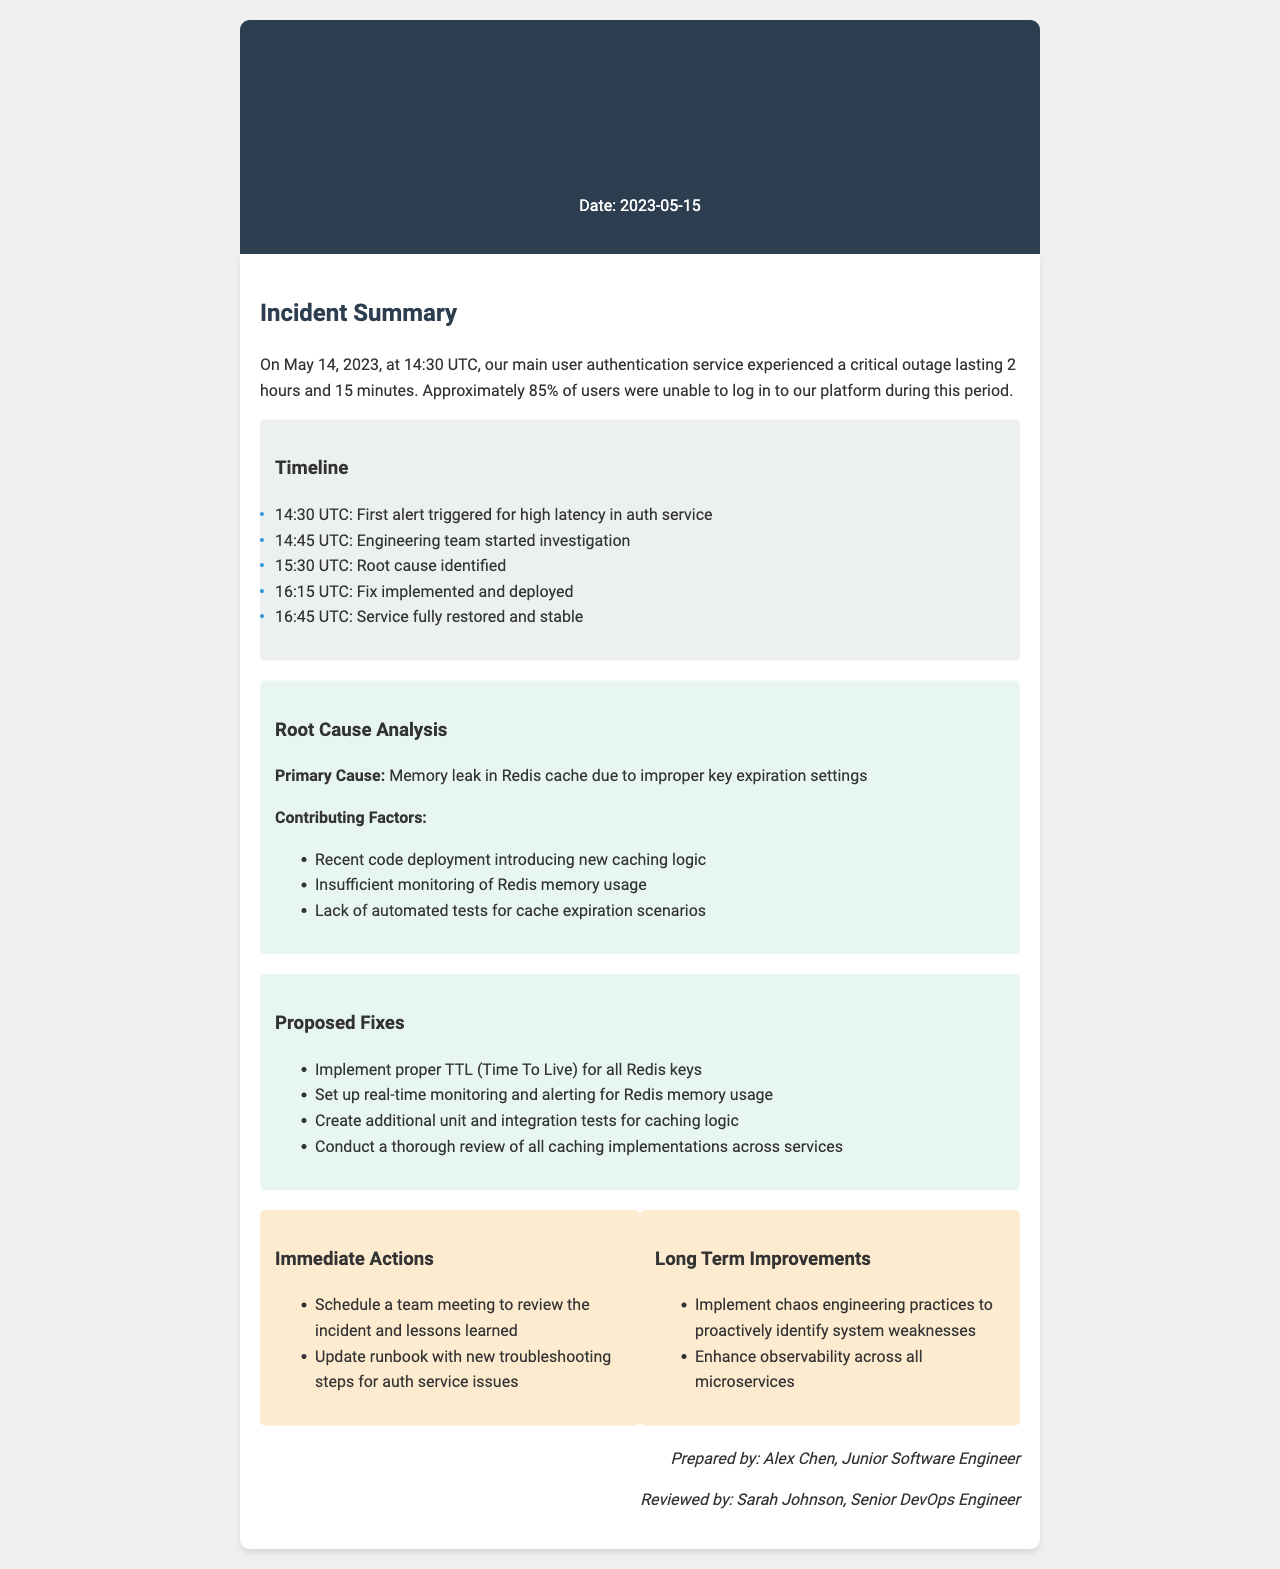What was the date of the incident? The incident occurred on May 14, 2023, as mentioned in the document.
Answer: May 14, 2023 How long did the outage last? The outage lasted for 2 hours and 15 minutes, as stated in the incident summary.
Answer: 2 hours and 15 minutes What was the primary cause of the outage? The primary cause of the outage was a memory leak in Redis cache, as highlighted in the root cause analysis section.
Answer: Memory leak in Redis cache Who prepared the incident report? The report was prepared by Alex Chen, noted in the footer of the document.
Answer: Alex Chen What percentage of users were affected? Approximately 85% of users were unable to log in, according to the incident summary.
Answer: 85% What immediate action is planned after the incident? One immediate action is to schedule a team meeting to review the incident and lessons learned.
Answer: Schedule a team meeting What is one proposed fix related to Redis? Implement proper TTL (Time To Live) for all Redis keys is one of the proposed fixes.
Answer: Implement proper TTL What time was the first alert triggered? The first alert was triggered at 14:30 UTC, as listed in the timeline.
Answer: 14:30 UTC What long-term improvement is suggested? Enhance observability across all microservices is suggested as a long-term improvement.
Answer: Enhance observability 